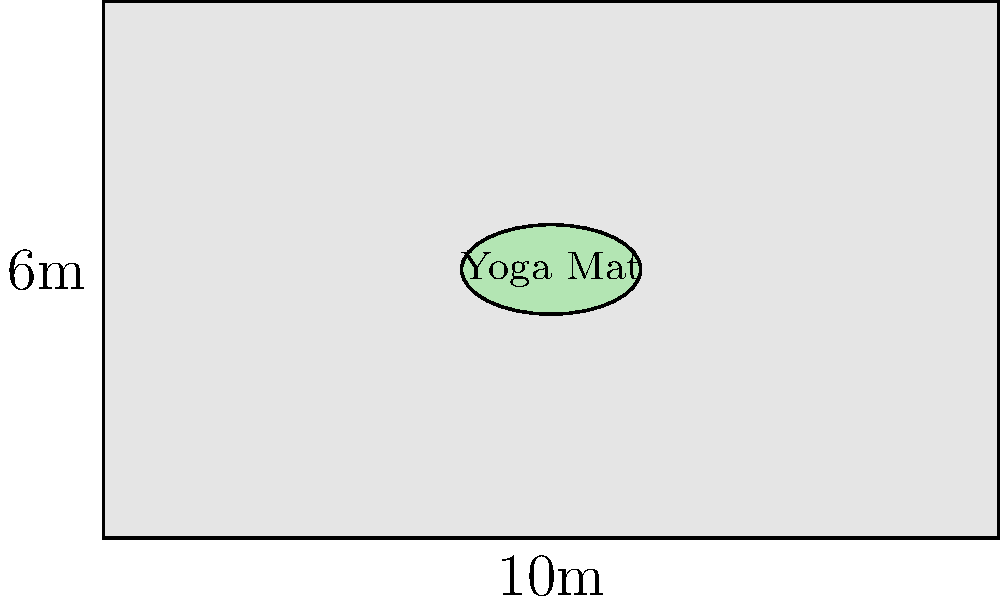A rectangular yoga studio measures 10 meters by 6 meters. Each yoga mat is represented by an ellipse with a major axis of 2 meters and a minor axis of 1 meter. What is the maximum number of non-overlapping yoga mats that can be placed in the studio, assuming they are arranged in a grid pattern with their centers equally spaced? Express your answer in terms of the floor function $\lfloor x \rfloor$, which gives the largest integer less than or equal to $x$. To solve this optimization problem, we'll follow these steps:

1) First, let's consider the spacing between mat centers:
   - In the length (10m) direction: 2m for the mat + minimum space between mats
   - In the width (6m) direction: 1m for the mat + minimum space between mats

2) Let's say the minimum space between mats is $x$ meters. Then:
   - Spacing in length direction = $2 + x$ meters
   - Spacing in width direction = $1 + x$ meters

3) The number of mats that can fit in each direction is:
   - Length: $\lfloor \frac{10}{2+x} \rfloor$
   - Width: $\lfloor \frac{6}{1+x} \rfloor$

4) The total number of mats is the product of these two:
   $N(x) = \lfloor \frac{10}{2+x} \rfloor \cdot \lfloor \frac{6}{1+x} \rfloor$

5) To maximize this, we need to minimize $x$ while keeping it positive. The practical minimum for $x$ would be around 0.5m to allow for movement between mats.

6) With $x = 0.5$:
   $N(0.5) = \lfloor \frac{10}{2.5} \rfloor \cdot \lfloor \frac{6}{1.5} \rfloor = 4 \cdot 4 = 16$

Therefore, the maximum number of mats is 16, which can be expressed as:
$\lfloor \frac{10}{2.5} \rfloor \cdot \lfloor \frac{6}{1.5} \rfloor$
Answer: $\lfloor \frac{10}{2.5} \rfloor \cdot \lfloor \frac{6}{1.5} \rfloor$ 